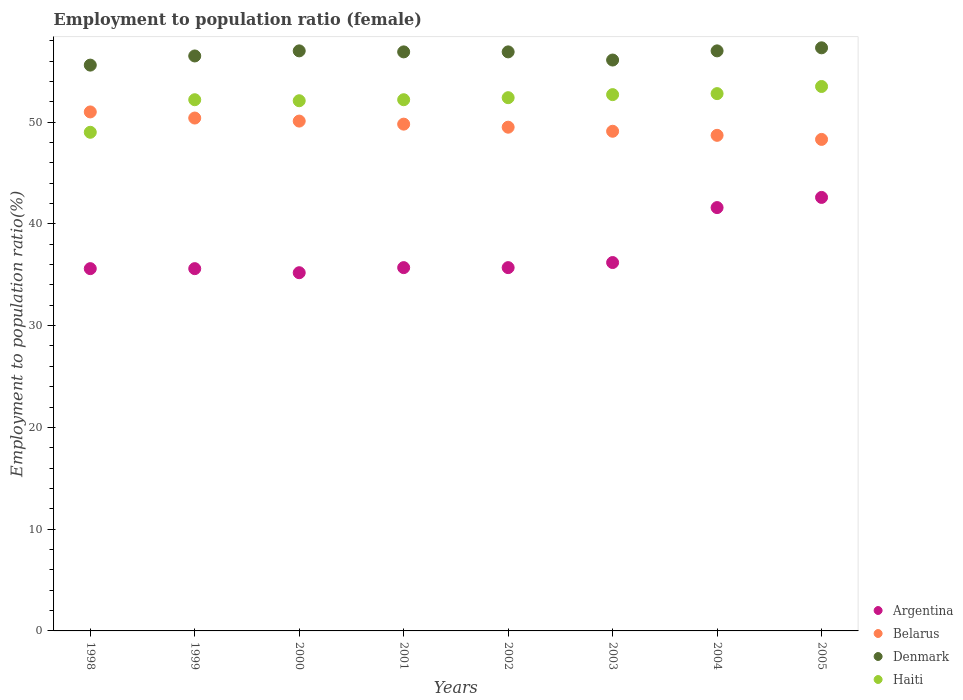What is the employment to population ratio in Denmark in 2001?
Your answer should be very brief. 56.9. Across all years, what is the maximum employment to population ratio in Haiti?
Make the answer very short. 53.5. Across all years, what is the minimum employment to population ratio in Belarus?
Provide a succinct answer. 48.3. In which year was the employment to population ratio in Denmark minimum?
Ensure brevity in your answer.  1998. What is the total employment to population ratio in Argentina in the graph?
Keep it short and to the point. 298.2. What is the difference between the employment to population ratio in Belarus in 2001 and that in 2003?
Provide a succinct answer. 0.7. What is the difference between the employment to population ratio in Denmark in 2000 and the employment to population ratio in Argentina in 2001?
Keep it short and to the point. 21.3. What is the average employment to population ratio in Haiti per year?
Give a very brief answer. 52.11. In the year 2003, what is the difference between the employment to population ratio in Argentina and employment to population ratio in Denmark?
Offer a very short reply. -19.9. What is the ratio of the employment to population ratio in Argentina in 1999 to that in 2005?
Offer a terse response. 0.84. Is the employment to population ratio in Belarus in 1999 less than that in 2002?
Your answer should be very brief. No. Is the difference between the employment to population ratio in Argentina in 2001 and 2002 greater than the difference between the employment to population ratio in Denmark in 2001 and 2002?
Give a very brief answer. No. In how many years, is the employment to population ratio in Haiti greater than the average employment to population ratio in Haiti taken over all years?
Give a very brief answer. 6. Is the sum of the employment to population ratio in Haiti in 2000 and 2001 greater than the maximum employment to population ratio in Belarus across all years?
Give a very brief answer. Yes. Is it the case that in every year, the sum of the employment to population ratio in Denmark and employment to population ratio in Belarus  is greater than the sum of employment to population ratio in Haiti and employment to population ratio in Argentina?
Provide a succinct answer. No. Is it the case that in every year, the sum of the employment to population ratio in Denmark and employment to population ratio in Belarus  is greater than the employment to population ratio in Haiti?
Provide a succinct answer. Yes. Does the employment to population ratio in Argentina monotonically increase over the years?
Offer a terse response. No. Is the employment to population ratio in Argentina strictly less than the employment to population ratio in Haiti over the years?
Keep it short and to the point. Yes. How many dotlines are there?
Your response must be concise. 4. Does the graph contain any zero values?
Keep it short and to the point. No. Where does the legend appear in the graph?
Ensure brevity in your answer.  Bottom right. How many legend labels are there?
Make the answer very short. 4. What is the title of the graph?
Provide a short and direct response. Employment to population ratio (female). Does "Liechtenstein" appear as one of the legend labels in the graph?
Your answer should be compact. No. What is the label or title of the X-axis?
Make the answer very short. Years. What is the Employment to population ratio(%) in Argentina in 1998?
Keep it short and to the point. 35.6. What is the Employment to population ratio(%) in Belarus in 1998?
Provide a short and direct response. 51. What is the Employment to population ratio(%) of Denmark in 1998?
Your answer should be very brief. 55.6. What is the Employment to population ratio(%) of Argentina in 1999?
Ensure brevity in your answer.  35.6. What is the Employment to population ratio(%) of Belarus in 1999?
Your response must be concise. 50.4. What is the Employment to population ratio(%) in Denmark in 1999?
Ensure brevity in your answer.  56.5. What is the Employment to population ratio(%) in Haiti in 1999?
Your response must be concise. 52.2. What is the Employment to population ratio(%) of Argentina in 2000?
Your answer should be very brief. 35.2. What is the Employment to population ratio(%) of Belarus in 2000?
Offer a very short reply. 50.1. What is the Employment to population ratio(%) in Denmark in 2000?
Provide a short and direct response. 57. What is the Employment to population ratio(%) in Haiti in 2000?
Give a very brief answer. 52.1. What is the Employment to population ratio(%) of Argentina in 2001?
Your answer should be very brief. 35.7. What is the Employment to population ratio(%) of Belarus in 2001?
Offer a very short reply. 49.8. What is the Employment to population ratio(%) in Denmark in 2001?
Make the answer very short. 56.9. What is the Employment to population ratio(%) in Haiti in 2001?
Ensure brevity in your answer.  52.2. What is the Employment to population ratio(%) of Argentina in 2002?
Make the answer very short. 35.7. What is the Employment to population ratio(%) of Belarus in 2002?
Your response must be concise. 49.5. What is the Employment to population ratio(%) of Denmark in 2002?
Your answer should be compact. 56.9. What is the Employment to population ratio(%) in Haiti in 2002?
Give a very brief answer. 52.4. What is the Employment to population ratio(%) in Argentina in 2003?
Your answer should be very brief. 36.2. What is the Employment to population ratio(%) in Belarus in 2003?
Your response must be concise. 49.1. What is the Employment to population ratio(%) of Denmark in 2003?
Offer a very short reply. 56.1. What is the Employment to population ratio(%) of Haiti in 2003?
Your response must be concise. 52.7. What is the Employment to population ratio(%) in Argentina in 2004?
Your answer should be compact. 41.6. What is the Employment to population ratio(%) of Belarus in 2004?
Give a very brief answer. 48.7. What is the Employment to population ratio(%) of Denmark in 2004?
Your answer should be very brief. 57. What is the Employment to population ratio(%) of Haiti in 2004?
Your answer should be compact. 52.8. What is the Employment to population ratio(%) in Argentina in 2005?
Provide a short and direct response. 42.6. What is the Employment to population ratio(%) of Belarus in 2005?
Your response must be concise. 48.3. What is the Employment to population ratio(%) of Denmark in 2005?
Your answer should be compact. 57.3. What is the Employment to population ratio(%) in Haiti in 2005?
Offer a very short reply. 53.5. Across all years, what is the maximum Employment to population ratio(%) of Argentina?
Your answer should be very brief. 42.6. Across all years, what is the maximum Employment to population ratio(%) of Denmark?
Ensure brevity in your answer.  57.3. Across all years, what is the maximum Employment to population ratio(%) of Haiti?
Provide a succinct answer. 53.5. Across all years, what is the minimum Employment to population ratio(%) in Argentina?
Keep it short and to the point. 35.2. Across all years, what is the minimum Employment to population ratio(%) in Belarus?
Keep it short and to the point. 48.3. Across all years, what is the minimum Employment to population ratio(%) in Denmark?
Your answer should be very brief. 55.6. What is the total Employment to population ratio(%) in Argentina in the graph?
Your answer should be compact. 298.2. What is the total Employment to population ratio(%) in Belarus in the graph?
Offer a terse response. 396.9. What is the total Employment to population ratio(%) of Denmark in the graph?
Ensure brevity in your answer.  453.3. What is the total Employment to population ratio(%) of Haiti in the graph?
Make the answer very short. 416.9. What is the difference between the Employment to population ratio(%) of Denmark in 1998 and that in 2000?
Make the answer very short. -1.4. What is the difference between the Employment to population ratio(%) in Haiti in 1998 and that in 2000?
Offer a terse response. -3.1. What is the difference between the Employment to population ratio(%) of Argentina in 1998 and that in 2001?
Your answer should be very brief. -0.1. What is the difference between the Employment to population ratio(%) of Belarus in 1998 and that in 2001?
Provide a succinct answer. 1.2. What is the difference between the Employment to population ratio(%) in Haiti in 1998 and that in 2001?
Ensure brevity in your answer.  -3.2. What is the difference between the Employment to population ratio(%) in Belarus in 1998 and that in 2002?
Ensure brevity in your answer.  1.5. What is the difference between the Employment to population ratio(%) of Denmark in 1998 and that in 2002?
Your response must be concise. -1.3. What is the difference between the Employment to population ratio(%) of Haiti in 1998 and that in 2002?
Offer a terse response. -3.4. What is the difference between the Employment to population ratio(%) in Belarus in 1998 and that in 2003?
Your response must be concise. 1.9. What is the difference between the Employment to population ratio(%) of Denmark in 1998 and that in 2003?
Offer a very short reply. -0.5. What is the difference between the Employment to population ratio(%) in Haiti in 1998 and that in 2003?
Offer a terse response. -3.7. What is the difference between the Employment to population ratio(%) of Argentina in 1998 and that in 2004?
Your answer should be very brief. -6. What is the difference between the Employment to population ratio(%) of Belarus in 1998 and that in 2004?
Give a very brief answer. 2.3. What is the difference between the Employment to population ratio(%) of Haiti in 1998 and that in 2004?
Keep it short and to the point. -3.8. What is the difference between the Employment to population ratio(%) of Argentina in 1998 and that in 2005?
Offer a terse response. -7. What is the difference between the Employment to population ratio(%) of Haiti in 1998 and that in 2005?
Provide a short and direct response. -4.5. What is the difference between the Employment to population ratio(%) in Denmark in 1999 and that in 2000?
Offer a very short reply. -0.5. What is the difference between the Employment to population ratio(%) in Denmark in 1999 and that in 2002?
Provide a short and direct response. -0.4. What is the difference between the Employment to population ratio(%) of Haiti in 1999 and that in 2002?
Keep it short and to the point. -0.2. What is the difference between the Employment to population ratio(%) of Belarus in 1999 and that in 2004?
Keep it short and to the point. 1.7. What is the difference between the Employment to population ratio(%) in Denmark in 1999 and that in 2004?
Ensure brevity in your answer.  -0.5. What is the difference between the Employment to population ratio(%) of Haiti in 1999 and that in 2004?
Offer a very short reply. -0.6. What is the difference between the Employment to population ratio(%) of Belarus in 1999 and that in 2005?
Give a very brief answer. 2.1. What is the difference between the Employment to population ratio(%) of Denmark in 1999 and that in 2005?
Ensure brevity in your answer.  -0.8. What is the difference between the Employment to population ratio(%) of Belarus in 2000 and that in 2001?
Your response must be concise. 0.3. What is the difference between the Employment to population ratio(%) of Denmark in 2000 and that in 2001?
Make the answer very short. 0.1. What is the difference between the Employment to population ratio(%) in Haiti in 2000 and that in 2001?
Ensure brevity in your answer.  -0.1. What is the difference between the Employment to population ratio(%) in Argentina in 2000 and that in 2002?
Provide a short and direct response. -0.5. What is the difference between the Employment to population ratio(%) in Belarus in 2000 and that in 2002?
Your response must be concise. 0.6. What is the difference between the Employment to population ratio(%) of Belarus in 2000 and that in 2004?
Ensure brevity in your answer.  1.4. What is the difference between the Employment to population ratio(%) of Argentina in 2000 and that in 2005?
Your response must be concise. -7.4. What is the difference between the Employment to population ratio(%) of Belarus in 2000 and that in 2005?
Your response must be concise. 1.8. What is the difference between the Employment to population ratio(%) in Haiti in 2000 and that in 2005?
Provide a succinct answer. -1.4. What is the difference between the Employment to population ratio(%) of Belarus in 2001 and that in 2002?
Your answer should be compact. 0.3. What is the difference between the Employment to population ratio(%) of Haiti in 2001 and that in 2002?
Your response must be concise. -0.2. What is the difference between the Employment to population ratio(%) in Argentina in 2001 and that in 2003?
Your answer should be very brief. -0.5. What is the difference between the Employment to population ratio(%) of Belarus in 2001 and that in 2003?
Offer a terse response. 0.7. What is the difference between the Employment to population ratio(%) of Denmark in 2001 and that in 2003?
Make the answer very short. 0.8. What is the difference between the Employment to population ratio(%) in Argentina in 2001 and that in 2004?
Make the answer very short. -5.9. What is the difference between the Employment to population ratio(%) in Haiti in 2001 and that in 2004?
Offer a very short reply. -0.6. What is the difference between the Employment to population ratio(%) in Argentina in 2001 and that in 2005?
Provide a succinct answer. -6.9. What is the difference between the Employment to population ratio(%) of Belarus in 2001 and that in 2005?
Offer a terse response. 1.5. What is the difference between the Employment to population ratio(%) in Haiti in 2001 and that in 2005?
Keep it short and to the point. -1.3. What is the difference between the Employment to population ratio(%) of Argentina in 2002 and that in 2003?
Provide a succinct answer. -0.5. What is the difference between the Employment to population ratio(%) of Haiti in 2002 and that in 2003?
Your answer should be compact. -0.3. What is the difference between the Employment to population ratio(%) in Argentina in 2002 and that in 2004?
Ensure brevity in your answer.  -5.9. What is the difference between the Employment to population ratio(%) in Belarus in 2002 and that in 2004?
Provide a succinct answer. 0.8. What is the difference between the Employment to population ratio(%) in Argentina in 2002 and that in 2005?
Give a very brief answer. -6.9. What is the difference between the Employment to population ratio(%) in Belarus in 2002 and that in 2005?
Your answer should be compact. 1.2. What is the difference between the Employment to population ratio(%) in Denmark in 2002 and that in 2005?
Your response must be concise. -0.4. What is the difference between the Employment to population ratio(%) in Haiti in 2002 and that in 2005?
Provide a short and direct response. -1.1. What is the difference between the Employment to population ratio(%) of Argentina in 2003 and that in 2004?
Offer a very short reply. -5.4. What is the difference between the Employment to population ratio(%) of Haiti in 2003 and that in 2004?
Give a very brief answer. -0.1. What is the difference between the Employment to population ratio(%) of Denmark in 2003 and that in 2005?
Make the answer very short. -1.2. What is the difference between the Employment to population ratio(%) in Haiti in 2003 and that in 2005?
Ensure brevity in your answer.  -0.8. What is the difference between the Employment to population ratio(%) of Belarus in 2004 and that in 2005?
Your response must be concise. 0.4. What is the difference between the Employment to population ratio(%) of Argentina in 1998 and the Employment to population ratio(%) of Belarus in 1999?
Ensure brevity in your answer.  -14.8. What is the difference between the Employment to population ratio(%) of Argentina in 1998 and the Employment to population ratio(%) of Denmark in 1999?
Offer a terse response. -20.9. What is the difference between the Employment to population ratio(%) of Argentina in 1998 and the Employment to population ratio(%) of Haiti in 1999?
Keep it short and to the point. -16.6. What is the difference between the Employment to population ratio(%) in Argentina in 1998 and the Employment to population ratio(%) in Denmark in 2000?
Your answer should be very brief. -21.4. What is the difference between the Employment to population ratio(%) of Argentina in 1998 and the Employment to population ratio(%) of Haiti in 2000?
Keep it short and to the point. -16.5. What is the difference between the Employment to population ratio(%) in Belarus in 1998 and the Employment to population ratio(%) in Denmark in 2000?
Offer a very short reply. -6. What is the difference between the Employment to population ratio(%) in Belarus in 1998 and the Employment to population ratio(%) in Haiti in 2000?
Offer a very short reply. -1.1. What is the difference between the Employment to population ratio(%) of Argentina in 1998 and the Employment to population ratio(%) of Belarus in 2001?
Keep it short and to the point. -14.2. What is the difference between the Employment to population ratio(%) in Argentina in 1998 and the Employment to population ratio(%) in Denmark in 2001?
Offer a terse response. -21.3. What is the difference between the Employment to population ratio(%) of Argentina in 1998 and the Employment to population ratio(%) of Haiti in 2001?
Ensure brevity in your answer.  -16.6. What is the difference between the Employment to population ratio(%) in Belarus in 1998 and the Employment to population ratio(%) in Denmark in 2001?
Provide a short and direct response. -5.9. What is the difference between the Employment to population ratio(%) of Argentina in 1998 and the Employment to population ratio(%) of Denmark in 2002?
Your response must be concise. -21.3. What is the difference between the Employment to population ratio(%) in Argentina in 1998 and the Employment to population ratio(%) in Haiti in 2002?
Provide a succinct answer. -16.8. What is the difference between the Employment to population ratio(%) of Denmark in 1998 and the Employment to population ratio(%) of Haiti in 2002?
Give a very brief answer. 3.2. What is the difference between the Employment to population ratio(%) of Argentina in 1998 and the Employment to population ratio(%) of Belarus in 2003?
Your response must be concise. -13.5. What is the difference between the Employment to population ratio(%) in Argentina in 1998 and the Employment to population ratio(%) in Denmark in 2003?
Make the answer very short. -20.5. What is the difference between the Employment to population ratio(%) of Argentina in 1998 and the Employment to population ratio(%) of Haiti in 2003?
Give a very brief answer. -17.1. What is the difference between the Employment to population ratio(%) of Belarus in 1998 and the Employment to population ratio(%) of Denmark in 2003?
Keep it short and to the point. -5.1. What is the difference between the Employment to population ratio(%) of Belarus in 1998 and the Employment to population ratio(%) of Haiti in 2003?
Make the answer very short. -1.7. What is the difference between the Employment to population ratio(%) in Argentina in 1998 and the Employment to population ratio(%) in Belarus in 2004?
Offer a terse response. -13.1. What is the difference between the Employment to population ratio(%) of Argentina in 1998 and the Employment to population ratio(%) of Denmark in 2004?
Make the answer very short. -21.4. What is the difference between the Employment to population ratio(%) of Argentina in 1998 and the Employment to population ratio(%) of Haiti in 2004?
Provide a succinct answer. -17.2. What is the difference between the Employment to population ratio(%) of Argentina in 1998 and the Employment to population ratio(%) of Belarus in 2005?
Your response must be concise. -12.7. What is the difference between the Employment to population ratio(%) in Argentina in 1998 and the Employment to population ratio(%) in Denmark in 2005?
Make the answer very short. -21.7. What is the difference between the Employment to population ratio(%) in Argentina in 1998 and the Employment to population ratio(%) in Haiti in 2005?
Provide a succinct answer. -17.9. What is the difference between the Employment to population ratio(%) in Belarus in 1998 and the Employment to population ratio(%) in Denmark in 2005?
Make the answer very short. -6.3. What is the difference between the Employment to population ratio(%) of Belarus in 1998 and the Employment to population ratio(%) of Haiti in 2005?
Offer a very short reply. -2.5. What is the difference between the Employment to population ratio(%) in Denmark in 1998 and the Employment to population ratio(%) in Haiti in 2005?
Your answer should be very brief. 2.1. What is the difference between the Employment to population ratio(%) in Argentina in 1999 and the Employment to population ratio(%) in Denmark in 2000?
Give a very brief answer. -21.4. What is the difference between the Employment to population ratio(%) of Argentina in 1999 and the Employment to population ratio(%) of Haiti in 2000?
Keep it short and to the point. -16.5. What is the difference between the Employment to population ratio(%) in Denmark in 1999 and the Employment to population ratio(%) in Haiti in 2000?
Provide a succinct answer. 4.4. What is the difference between the Employment to population ratio(%) of Argentina in 1999 and the Employment to population ratio(%) of Denmark in 2001?
Provide a short and direct response. -21.3. What is the difference between the Employment to population ratio(%) in Argentina in 1999 and the Employment to population ratio(%) in Haiti in 2001?
Provide a succinct answer. -16.6. What is the difference between the Employment to population ratio(%) of Belarus in 1999 and the Employment to population ratio(%) of Haiti in 2001?
Give a very brief answer. -1.8. What is the difference between the Employment to population ratio(%) of Argentina in 1999 and the Employment to population ratio(%) of Denmark in 2002?
Make the answer very short. -21.3. What is the difference between the Employment to population ratio(%) of Argentina in 1999 and the Employment to population ratio(%) of Haiti in 2002?
Provide a short and direct response. -16.8. What is the difference between the Employment to population ratio(%) of Belarus in 1999 and the Employment to population ratio(%) of Denmark in 2002?
Your answer should be very brief. -6.5. What is the difference between the Employment to population ratio(%) of Belarus in 1999 and the Employment to population ratio(%) of Haiti in 2002?
Ensure brevity in your answer.  -2. What is the difference between the Employment to population ratio(%) of Argentina in 1999 and the Employment to population ratio(%) of Denmark in 2003?
Your answer should be compact. -20.5. What is the difference between the Employment to population ratio(%) in Argentina in 1999 and the Employment to population ratio(%) in Haiti in 2003?
Offer a terse response. -17.1. What is the difference between the Employment to population ratio(%) of Belarus in 1999 and the Employment to population ratio(%) of Denmark in 2003?
Your response must be concise. -5.7. What is the difference between the Employment to population ratio(%) of Denmark in 1999 and the Employment to population ratio(%) of Haiti in 2003?
Your answer should be very brief. 3.8. What is the difference between the Employment to population ratio(%) in Argentina in 1999 and the Employment to population ratio(%) in Denmark in 2004?
Keep it short and to the point. -21.4. What is the difference between the Employment to population ratio(%) of Argentina in 1999 and the Employment to population ratio(%) of Haiti in 2004?
Offer a very short reply. -17.2. What is the difference between the Employment to population ratio(%) of Belarus in 1999 and the Employment to population ratio(%) of Denmark in 2004?
Provide a succinct answer. -6.6. What is the difference between the Employment to population ratio(%) in Belarus in 1999 and the Employment to population ratio(%) in Haiti in 2004?
Provide a short and direct response. -2.4. What is the difference between the Employment to population ratio(%) in Denmark in 1999 and the Employment to population ratio(%) in Haiti in 2004?
Your answer should be very brief. 3.7. What is the difference between the Employment to population ratio(%) of Argentina in 1999 and the Employment to population ratio(%) of Belarus in 2005?
Ensure brevity in your answer.  -12.7. What is the difference between the Employment to population ratio(%) in Argentina in 1999 and the Employment to population ratio(%) in Denmark in 2005?
Your answer should be compact. -21.7. What is the difference between the Employment to population ratio(%) in Argentina in 1999 and the Employment to population ratio(%) in Haiti in 2005?
Give a very brief answer. -17.9. What is the difference between the Employment to population ratio(%) of Belarus in 1999 and the Employment to population ratio(%) of Haiti in 2005?
Your answer should be compact. -3.1. What is the difference between the Employment to population ratio(%) of Argentina in 2000 and the Employment to population ratio(%) of Belarus in 2001?
Your answer should be compact. -14.6. What is the difference between the Employment to population ratio(%) in Argentina in 2000 and the Employment to population ratio(%) in Denmark in 2001?
Provide a short and direct response. -21.7. What is the difference between the Employment to population ratio(%) of Argentina in 2000 and the Employment to population ratio(%) of Haiti in 2001?
Your answer should be compact. -17. What is the difference between the Employment to population ratio(%) in Belarus in 2000 and the Employment to population ratio(%) in Denmark in 2001?
Ensure brevity in your answer.  -6.8. What is the difference between the Employment to population ratio(%) of Denmark in 2000 and the Employment to population ratio(%) of Haiti in 2001?
Ensure brevity in your answer.  4.8. What is the difference between the Employment to population ratio(%) in Argentina in 2000 and the Employment to population ratio(%) in Belarus in 2002?
Your answer should be compact. -14.3. What is the difference between the Employment to population ratio(%) in Argentina in 2000 and the Employment to population ratio(%) in Denmark in 2002?
Offer a terse response. -21.7. What is the difference between the Employment to population ratio(%) of Argentina in 2000 and the Employment to population ratio(%) of Haiti in 2002?
Offer a very short reply. -17.2. What is the difference between the Employment to population ratio(%) of Belarus in 2000 and the Employment to population ratio(%) of Denmark in 2002?
Provide a succinct answer. -6.8. What is the difference between the Employment to population ratio(%) of Belarus in 2000 and the Employment to population ratio(%) of Haiti in 2002?
Provide a short and direct response. -2.3. What is the difference between the Employment to population ratio(%) of Argentina in 2000 and the Employment to population ratio(%) of Denmark in 2003?
Provide a succinct answer. -20.9. What is the difference between the Employment to population ratio(%) in Argentina in 2000 and the Employment to population ratio(%) in Haiti in 2003?
Keep it short and to the point. -17.5. What is the difference between the Employment to population ratio(%) in Argentina in 2000 and the Employment to population ratio(%) in Belarus in 2004?
Give a very brief answer. -13.5. What is the difference between the Employment to population ratio(%) in Argentina in 2000 and the Employment to population ratio(%) in Denmark in 2004?
Your answer should be compact. -21.8. What is the difference between the Employment to population ratio(%) in Argentina in 2000 and the Employment to population ratio(%) in Haiti in 2004?
Your answer should be very brief. -17.6. What is the difference between the Employment to population ratio(%) in Belarus in 2000 and the Employment to population ratio(%) in Haiti in 2004?
Provide a short and direct response. -2.7. What is the difference between the Employment to population ratio(%) in Argentina in 2000 and the Employment to population ratio(%) in Denmark in 2005?
Provide a succinct answer. -22.1. What is the difference between the Employment to population ratio(%) of Argentina in 2000 and the Employment to population ratio(%) of Haiti in 2005?
Give a very brief answer. -18.3. What is the difference between the Employment to population ratio(%) in Belarus in 2000 and the Employment to population ratio(%) in Denmark in 2005?
Give a very brief answer. -7.2. What is the difference between the Employment to population ratio(%) in Belarus in 2000 and the Employment to population ratio(%) in Haiti in 2005?
Ensure brevity in your answer.  -3.4. What is the difference between the Employment to population ratio(%) of Denmark in 2000 and the Employment to population ratio(%) of Haiti in 2005?
Offer a very short reply. 3.5. What is the difference between the Employment to population ratio(%) in Argentina in 2001 and the Employment to population ratio(%) in Belarus in 2002?
Offer a terse response. -13.8. What is the difference between the Employment to population ratio(%) in Argentina in 2001 and the Employment to population ratio(%) in Denmark in 2002?
Provide a short and direct response. -21.2. What is the difference between the Employment to population ratio(%) in Argentina in 2001 and the Employment to population ratio(%) in Haiti in 2002?
Provide a short and direct response. -16.7. What is the difference between the Employment to population ratio(%) in Denmark in 2001 and the Employment to population ratio(%) in Haiti in 2002?
Your response must be concise. 4.5. What is the difference between the Employment to population ratio(%) of Argentina in 2001 and the Employment to population ratio(%) of Belarus in 2003?
Your response must be concise. -13.4. What is the difference between the Employment to population ratio(%) of Argentina in 2001 and the Employment to population ratio(%) of Denmark in 2003?
Keep it short and to the point. -20.4. What is the difference between the Employment to population ratio(%) of Argentina in 2001 and the Employment to population ratio(%) of Haiti in 2003?
Your answer should be very brief. -17. What is the difference between the Employment to population ratio(%) in Belarus in 2001 and the Employment to population ratio(%) in Haiti in 2003?
Provide a succinct answer. -2.9. What is the difference between the Employment to population ratio(%) of Argentina in 2001 and the Employment to population ratio(%) of Denmark in 2004?
Your answer should be compact. -21.3. What is the difference between the Employment to population ratio(%) in Argentina in 2001 and the Employment to population ratio(%) in Haiti in 2004?
Your answer should be very brief. -17.1. What is the difference between the Employment to population ratio(%) of Belarus in 2001 and the Employment to population ratio(%) of Haiti in 2004?
Give a very brief answer. -3. What is the difference between the Employment to population ratio(%) in Argentina in 2001 and the Employment to population ratio(%) in Denmark in 2005?
Keep it short and to the point. -21.6. What is the difference between the Employment to population ratio(%) of Argentina in 2001 and the Employment to population ratio(%) of Haiti in 2005?
Keep it short and to the point. -17.8. What is the difference between the Employment to population ratio(%) in Belarus in 2001 and the Employment to population ratio(%) in Haiti in 2005?
Give a very brief answer. -3.7. What is the difference between the Employment to population ratio(%) of Argentina in 2002 and the Employment to population ratio(%) of Denmark in 2003?
Your answer should be compact. -20.4. What is the difference between the Employment to population ratio(%) in Argentina in 2002 and the Employment to population ratio(%) in Haiti in 2003?
Provide a succinct answer. -17. What is the difference between the Employment to population ratio(%) in Belarus in 2002 and the Employment to population ratio(%) in Denmark in 2003?
Offer a very short reply. -6.6. What is the difference between the Employment to population ratio(%) of Denmark in 2002 and the Employment to population ratio(%) of Haiti in 2003?
Provide a short and direct response. 4.2. What is the difference between the Employment to population ratio(%) of Argentina in 2002 and the Employment to population ratio(%) of Denmark in 2004?
Provide a succinct answer. -21.3. What is the difference between the Employment to population ratio(%) in Argentina in 2002 and the Employment to population ratio(%) in Haiti in 2004?
Provide a short and direct response. -17.1. What is the difference between the Employment to population ratio(%) in Belarus in 2002 and the Employment to population ratio(%) in Denmark in 2004?
Your answer should be compact. -7.5. What is the difference between the Employment to population ratio(%) in Denmark in 2002 and the Employment to population ratio(%) in Haiti in 2004?
Your response must be concise. 4.1. What is the difference between the Employment to population ratio(%) of Argentina in 2002 and the Employment to population ratio(%) of Belarus in 2005?
Your answer should be compact. -12.6. What is the difference between the Employment to population ratio(%) of Argentina in 2002 and the Employment to population ratio(%) of Denmark in 2005?
Offer a very short reply. -21.6. What is the difference between the Employment to population ratio(%) in Argentina in 2002 and the Employment to population ratio(%) in Haiti in 2005?
Ensure brevity in your answer.  -17.8. What is the difference between the Employment to population ratio(%) in Belarus in 2002 and the Employment to population ratio(%) in Denmark in 2005?
Keep it short and to the point. -7.8. What is the difference between the Employment to population ratio(%) in Argentina in 2003 and the Employment to population ratio(%) in Belarus in 2004?
Your answer should be very brief. -12.5. What is the difference between the Employment to population ratio(%) of Argentina in 2003 and the Employment to population ratio(%) of Denmark in 2004?
Provide a succinct answer. -20.8. What is the difference between the Employment to population ratio(%) in Argentina in 2003 and the Employment to population ratio(%) in Haiti in 2004?
Your answer should be compact. -16.6. What is the difference between the Employment to population ratio(%) in Belarus in 2003 and the Employment to population ratio(%) in Denmark in 2004?
Keep it short and to the point. -7.9. What is the difference between the Employment to population ratio(%) of Belarus in 2003 and the Employment to population ratio(%) of Haiti in 2004?
Your response must be concise. -3.7. What is the difference between the Employment to population ratio(%) of Argentina in 2003 and the Employment to population ratio(%) of Belarus in 2005?
Ensure brevity in your answer.  -12.1. What is the difference between the Employment to population ratio(%) of Argentina in 2003 and the Employment to population ratio(%) of Denmark in 2005?
Give a very brief answer. -21.1. What is the difference between the Employment to population ratio(%) in Argentina in 2003 and the Employment to population ratio(%) in Haiti in 2005?
Provide a short and direct response. -17.3. What is the difference between the Employment to population ratio(%) of Belarus in 2003 and the Employment to population ratio(%) of Denmark in 2005?
Your response must be concise. -8.2. What is the difference between the Employment to population ratio(%) of Belarus in 2003 and the Employment to population ratio(%) of Haiti in 2005?
Your response must be concise. -4.4. What is the difference between the Employment to population ratio(%) in Argentina in 2004 and the Employment to population ratio(%) in Belarus in 2005?
Make the answer very short. -6.7. What is the difference between the Employment to population ratio(%) of Argentina in 2004 and the Employment to population ratio(%) of Denmark in 2005?
Your answer should be compact. -15.7. What is the difference between the Employment to population ratio(%) of Argentina in 2004 and the Employment to population ratio(%) of Haiti in 2005?
Your answer should be compact. -11.9. What is the difference between the Employment to population ratio(%) of Belarus in 2004 and the Employment to population ratio(%) of Denmark in 2005?
Provide a succinct answer. -8.6. What is the difference between the Employment to population ratio(%) of Belarus in 2004 and the Employment to population ratio(%) of Haiti in 2005?
Give a very brief answer. -4.8. What is the average Employment to population ratio(%) of Argentina per year?
Offer a very short reply. 37.27. What is the average Employment to population ratio(%) in Belarus per year?
Provide a succinct answer. 49.61. What is the average Employment to population ratio(%) in Denmark per year?
Keep it short and to the point. 56.66. What is the average Employment to population ratio(%) of Haiti per year?
Give a very brief answer. 52.11. In the year 1998, what is the difference between the Employment to population ratio(%) in Argentina and Employment to population ratio(%) in Belarus?
Offer a terse response. -15.4. In the year 1998, what is the difference between the Employment to population ratio(%) of Argentina and Employment to population ratio(%) of Denmark?
Keep it short and to the point. -20. In the year 1998, what is the difference between the Employment to population ratio(%) in Argentina and Employment to population ratio(%) in Haiti?
Give a very brief answer. -13.4. In the year 1998, what is the difference between the Employment to population ratio(%) of Belarus and Employment to population ratio(%) of Denmark?
Your response must be concise. -4.6. In the year 1998, what is the difference between the Employment to population ratio(%) in Belarus and Employment to population ratio(%) in Haiti?
Give a very brief answer. 2. In the year 1998, what is the difference between the Employment to population ratio(%) in Denmark and Employment to population ratio(%) in Haiti?
Your response must be concise. 6.6. In the year 1999, what is the difference between the Employment to population ratio(%) in Argentina and Employment to population ratio(%) in Belarus?
Ensure brevity in your answer.  -14.8. In the year 1999, what is the difference between the Employment to population ratio(%) of Argentina and Employment to population ratio(%) of Denmark?
Ensure brevity in your answer.  -20.9. In the year 1999, what is the difference between the Employment to population ratio(%) in Argentina and Employment to population ratio(%) in Haiti?
Provide a short and direct response. -16.6. In the year 1999, what is the difference between the Employment to population ratio(%) of Belarus and Employment to population ratio(%) of Denmark?
Give a very brief answer. -6.1. In the year 1999, what is the difference between the Employment to population ratio(%) of Belarus and Employment to population ratio(%) of Haiti?
Provide a short and direct response. -1.8. In the year 1999, what is the difference between the Employment to population ratio(%) in Denmark and Employment to population ratio(%) in Haiti?
Offer a very short reply. 4.3. In the year 2000, what is the difference between the Employment to population ratio(%) of Argentina and Employment to population ratio(%) of Belarus?
Provide a short and direct response. -14.9. In the year 2000, what is the difference between the Employment to population ratio(%) of Argentina and Employment to population ratio(%) of Denmark?
Offer a very short reply. -21.8. In the year 2000, what is the difference between the Employment to population ratio(%) of Argentina and Employment to population ratio(%) of Haiti?
Keep it short and to the point. -16.9. In the year 2000, what is the difference between the Employment to population ratio(%) in Denmark and Employment to population ratio(%) in Haiti?
Keep it short and to the point. 4.9. In the year 2001, what is the difference between the Employment to population ratio(%) in Argentina and Employment to population ratio(%) in Belarus?
Offer a terse response. -14.1. In the year 2001, what is the difference between the Employment to population ratio(%) in Argentina and Employment to population ratio(%) in Denmark?
Your response must be concise. -21.2. In the year 2001, what is the difference between the Employment to population ratio(%) in Argentina and Employment to population ratio(%) in Haiti?
Your response must be concise. -16.5. In the year 2002, what is the difference between the Employment to population ratio(%) of Argentina and Employment to population ratio(%) of Denmark?
Your answer should be very brief. -21.2. In the year 2002, what is the difference between the Employment to population ratio(%) of Argentina and Employment to population ratio(%) of Haiti?
Provide a succinct answer. -16.7. In the year 2002, what is the difference between the Employment to population ratio(%) in Belarus and Employment to population ratio(%) in Denmark?
Give a very brief answer. -7.4. In the year 2002, what is the difference between the Employment to population ratio(%) of Belarus and Employment to population ratio(%) of Haiti?
Offer a terse response. -2.9. In the year 2002, what is the difference between the Employment to population ratio(%) in Denmark and Employment to population ratio(%) in Haiti?
Provide a succinct answer. 4.5. In the year 2003, what is the difference between the Employment to population ratio(%) of Argentina and Employment to population ratio(%) of Denmark?
Your answer should be very brief. -19.9. In the year 2003, what is the difference between the Employment to population ratio(%) in Argentina and Employment to population ratio(%) in Haiti?
Provide a short and direct response. -16.5. In the year 2003, what is the difference between the Employment to population ratio(%) of Belarus and Employment to population ratio(%) of Denmark?
Keep it short and to the point. -7. In the year 2003, what is the difference between the Employment to population ratio(%) of Belarus and Employment to population ratio(%) of Haiti?
Provide a short and direct response. -3.6. In the year 2003, what is the difference between the Employment to population ratio(%) of Denmark and Employment to population ratio(%) of Haiti?
Make the answer very short. 3.4. In the year 2004, what is the difference between the Employment to population ratio(%) in Argentina and Employment to population ratio(%) in Belarus?
Give a very brief answer. -7.1. In the year 2004, what is the difference between the Employment to population ratio(%) of Argentina and Employment to population ratio(%) of Denmark?
Give a very brief answer. -15.4. In the year 2004, what is the difference between the Employment to population ratio(%) of Belarus and Employment to population ratio(%) of Denmark?
Offer a very short reply. -8.3. In the year 2004, what is the difference between the Employment to population ratio(%) of Denmark and Employment to population ratio(%) of Haiti?
Provide a succinct answer. 4.2. In the year 2005, what is the difference between the Employment to population ratio(%) of Argentina and Employment to population ratio(%) of Belarus?
Offer a terse response. -5.7. In the year 2005, what is the difference between the Employment to population ratio(%) in Argentina and Employment to population ratio(%) in Denmark?
Your response must be concise. -14.7. In the year 2005, what is the difference between the Employment to population ratio(%) of Belarus and Employment to population ratio(%) of Denmark?
Make the answer very short. -9. In the year 2005, what is the difference between the Employment to population ratio(%) in Denmark and Employment to population ratio(%) in Haiti?
Your answer should be compact. 3.8. What is the ratio of the Employment to population ratio(%) in Argentina in 1998 to that in 1999?
Offer a very short reply. 1. What is the ratio of the Employment to population ratio(%) of Belarus in 1998 to that in 1999?
Keep it short and to the point. 1.01. What is the ratio of the Employment to population ratio(%) of Denmark in 1998 to that in 1999?
Provide a succinct answer. 0.98. What is the ratio of the Employment to population ratio(%) of Haiti in 1998 to that in 1999?
Keep it short and to the point. 0.94. What is the ratio of the Employment to population ratio(%) in Argentina in 1998 to that in 2000?
Give a very brief answer. 1.01. What is the ratio of the Employment to population ratio(%) of Denmark in 1998 to that in 2000?
Offer a terse response. 0.98. What is the ratio of the Employment to population ratio(%) in Haiti in 1998 to that in 2000?
Your answer should be very brief. 0.94. What is the ratio of the Employment to population ratio(%) of Belarus in 1998 to that in 2001?
Your answer should be compact. 1.02. What is the ratio of the Employment to population ratio(%) in Denmark in 1998 to that in 2001?
Your answer should be compact. 0.98. What is the ratio of the Employment to population ratio(%) in Haiti in 1998 to that in 2001?
Offer a terse response. 0.94. What is the ratio of the Employment to population ratio(%) in Belarus in 1998 to that in 2002?
Your answer should be very brief. 1.03. What is the ratio of the Employment to population ratio(%) of Denmark in 1998 to that in 2002?
Your answer should be very brief. 0.98. What is the ratio of the Employment to population ratio(%) in Haiti in 1998 to that in 2002?
Give a very brief answer. 0.94. What is the ratio of the Employment to population ratio(%) in Argentina in 1998 to that in 2003?
Provide a short and direct response. 0.98. What is the ratio of the Employment to population ratio(%) in Belarus in 1998 to that in 2003?
Provide a succinct answer. 1.04. What is the ratio of the Employment to population ratio(%) of Haiti in 1998 to that in 2003?
Your response must be concise. 0.93. What is the ratio of the Employment to population ratio(%) of Argentina in 1998 to that in 2004?
Your answer should be very brief. 0.86. What is the ratio of the Employment to population ratio(%) in Belarus in 1998 to that in 2004?
Your response must be concise. 1.05. What is the ratio of the Employment to population ratio(%) of Denmark in 1998 to that in 2004?
Give a very brief answer. 0.98. What is the ratio of the Employment to population ratio(%) of Haiti in 1998 to that in 2004?
Provide a succinct answer. 0.93. What is the ratio of the Employment to population ratio(%) in Argentina in 1998 to that in 2005?
Ensure brevity in your answer.  0.84. What is the ratio of the Employment to population ratio(%) in Belarus in 1998 to that in 2005?
Keep it short and to the point. 1.06. What is the ratio of the Employment to population ratio(%) in Denmark in 1998 to that in 2005?
Provide a short and direct response. 0.97. What is the ratio of the Employment to population ratio(%) of Haiti in 1998 to that in 2005?
Your answer should be compact. 0.92. What is the ratio of the Employment to population ratio(%) of Argentina in 1999 to that in 2000?
Provide a succinct answer. 1.01. What is the ratio of the Employment to population ratio(%) in Belarus in 1999 to that in 2000?
Make the answer very short. 1.01. What is the ratio of the Employment to population ratio(%) of Denmark in 1999 to that in 2000?
Provide a succinct answer. 0.99. What is the ratio of the Employment to population ratio(%) of Denmark in 1999 to that in 2001?
Your answer should be compact. 0.99. What is the ratio of the Employment to population ratio(%) of Haiti in 1999 to that in 2001?
Ensure brevity in your answer.  1. What is the ratio of the Employment to population ratio(%) of Belarus in 1999 to that in 2002?
Give a very brief answer. 1.02. What is the ratio of the Employment to population ratio(%) in Haiti in 1999 to that in 2002?
Your answer should be very brief. 1. What is the ratio of the Employment to population ratio(%) in Argentina in 1999 to that in 2003?
Provide a succinct answer. 0.98. What is the ratio of the Employment to population ratio(%) in Belarus in 1999 to that in 2003?
Offer a terse response. 1.03. What is the ratio of the Employment to population ratio(%) of Denmark in 1999 to that in 2003?
Your answer should be very brief. 1.01. What is the ratio of the Employment to population ratio(%) of Argentina in 1999 to that in 2004?
Keep it short and to the point. 0.86. What is the ratio of the Employment to population ratio(%) in Belarus in 1999 to that in 2004?
Make the answer very short. 1.03. What is the ratio of the Employment to population ratio(%) in Argentina in 1999 to that in 2005?
Give a very brief answer. 0.84. What is the ratio of the Employment to population ratio(%) of Belarus in 1999 to that in 2005?
Your answer should be very brief. 1.04. What is the ratio of the Employment to population ratio(%) of Haiti in 1999 to that in 2005?
Your response must be concise. 0.98. What is the ratio of the Employment to population ratio(%) of Argentina in 2000 to that in 2001?
Provide a succinct answer. 0.99. What is the ratio of the Employment to population ratio(%) of Denmark in 2000 to that in 2001?
Give a very brief answer. 1. What is the ratio of the Employment to population ratio(%) of Haiti in 2000 to that in 2001?
Your answer should be compact. 1. What is the ratio of the Employment to population ratio(%) in Argentina in 2000 to that in 2002?
Keep it short and to the point. 0.99. What is the ratio of the Employment to population ratio(%) of Belarus in 2000 to that in 2002?
Ensure brevity in your answer.  1.01. What is the ratio of the Employment to population ratio(%) in Denmark in 2000 to that in 2002?
Your response must be concise. 1. What is the ratio of the Employment to population ratio(%) of Argentina in 2000 to that in 2003?
Make the answer very short. 0.97. What is the ratio of the Employment to population ratio(%) of Belarus in 2000 to that in 2003?
Give a very brief answer. 1.02. What is the ratio of the Employment to population ratio(%) of Haiti in 2000 to that in 2003?
Provide a succinct answer. 0.99. What is the ratio of the Employment to population ratio(%) in Argentina in 2000 to that in 2004?
Your response must be concise. 0.85. What is the ratio of the Employment to population ratio(%) in Belarus in 2000 to that in 2004?
Make the answer very short. 1.03. What is the ratio of the Employment to population ratio(%) of Denmark in 2000 to that in 2004?
Provide a short and direct response. 1. What is the ratio of the Employment to population ratio(%) of Haiti in 2000 to that in 2004?
Keep it short and to the point. 0.99. What is the ratio of the Employment to population ratio(%) of Argentina in 2000 to that in 2005?
Your answer should be very brief. 0.83. What is the ratio of the Employment to population ratio(%) in Belarus in 2000 to that in 2005?
Your response must be concise. 1.04. What is the ratio of the Employment to population ratio(%) of Denmark in 2000 to that in 2005?
Ensure brevity in your answer.  0.99. What is the ratio of the Employment to population ratio(%) of Haiti in 2000 to that in 2005?
Offer a terse response. 0.97. What is the ratio of the Employment to population ratio(%) in Haiti in 2001 to that in 2002?
Your response must be concise. 1. What is the ratio of the Employment to population ratio(%) of Argentina in 2001 to that in 2003?
Provide a succinct answer. 0.99. What is the ratio of the Employment to population ratio(%) in Belarus in 2001 to that in 2003?
Offer a very short reply. 1.01. What is the ratio of the Employment to population ratio(%) in Denmark in 2001 to that in 2003?
Offer a very short reply. 1.01. What is the ratio of the Employment to population ratio(%) of Argentina in 2001 to that in 2004?
Give a very brief answer. 0.86. What is the ratio of the Employment to population ratio(%) in Belarus in 2001 to that in 2004?
Make the answer very short. 1.02. What is the ratio of the Employment to population ratio(%) of Haiti in 2001 to that in 2004?
Give a very brief answer. 0.99. What is the ratio of the Employment to population ratio(%) of Argentina in 2001 to that in 2005?
Offer a terse response. 0.84. What is the ratio of the Employment to population ratio(%) in Belarus in 2001 to that in 2005?
Provide a succinct answer. 1.03. What is the ratio of the Employment to population ratio(%) in Haiti in 2001 to that in 2005?
Provide a succinct answer. 0.98. What is the ratio of the Employment to population ratio(%) of Argentina in 2002 to that in 2003?
Ensure brevity in your answer.  0.99. What is the ratio of the Employment to population ratio(%) in Denmark in 2002 to that in 2003?
Your answer should be very brief. 1.01. What is the ratio of the Employment to population ratio(%) in Haiti in 2002 to that in 2003?
Offer a very short reply. 0.99. What is the ratio of the Employment to population ratio(%) of Argentina in 2002 to that in 2004?
Your answer should be compact. 0.86. What is the ratio of the Employment to population ratio(%) of Belarus in 2002 to that in 2004?
Provide a succinct answer. 1.02. What is the ratio of the Employment to population ratio(%) of Haiti in 2002 to that in 2004?
Offer a terse response. 0.99. What is the ratio of the Employment to population ratio(%) in Argentina in 2002 to that in 2005?
Ensure brevity in your answer.  0.84. What is the ratio of the Employment to population ratio(%) in Belarus in 2002 to that in 2005?
Ensure brevity in your answer.  1.02. What is the ratio of the Employment to population ratio(%) in Haiti in 2002 to that in 2005?
Provide a succinct answer. 0.98. What is the ratio of the Employment to population ratio(%) of Argentina in 2003 to that in 2004?
Provide a short and direct response. 0.87. What is the ratio of the Employment to population ratio(%) of Belarus in 2003 to that in 2004?
Ensure brevity in your answer.  1.01. What is the ratio of the Employment to population ratio(%) of Denmark in 2003 to that in 2004?
Offer a terse response. 0.98. What is the ratio of the Employment to population ratio(%) of Argentina in 2003 to that in 2005?
Offer a terse response. 0.85. What is the ratio of the Employment to population ratio(%) in Belarus in 2003 to that in 2005?
Offer a terse response. 1.02. What is the ratio of the Employment to population ratio(%) in Denmark in 2003 to that in 2005?
Provide a short and direct response. 0.98. What is the ratio of the Employment to population ratio(%) of Argentina in 2004 to that in 2005?
Provide a succinct answer. 0.98. What is the ratio of the Employment to population ratio(%) of Belarus in 2004 to that in 2005?
Your answer should be very brief. 1.01. What is the ratio of the Employment to population ratio(%) in Haiti in 2004 to that in 2005?
Provide a short and direct response. 0.99. What is the difference between the highest and the second highest Employment to population ratio(%) of Argentina?
Keep it short and to the point. 1. What is the difference between the highest and the second highest Employment to population ratio(%) in Belarus?
Your response must be concise. 0.6. What is the difference between the highest and the lowest Employment to population ratio(%) in Argentina?
Offer a very short reply. 7.4. 